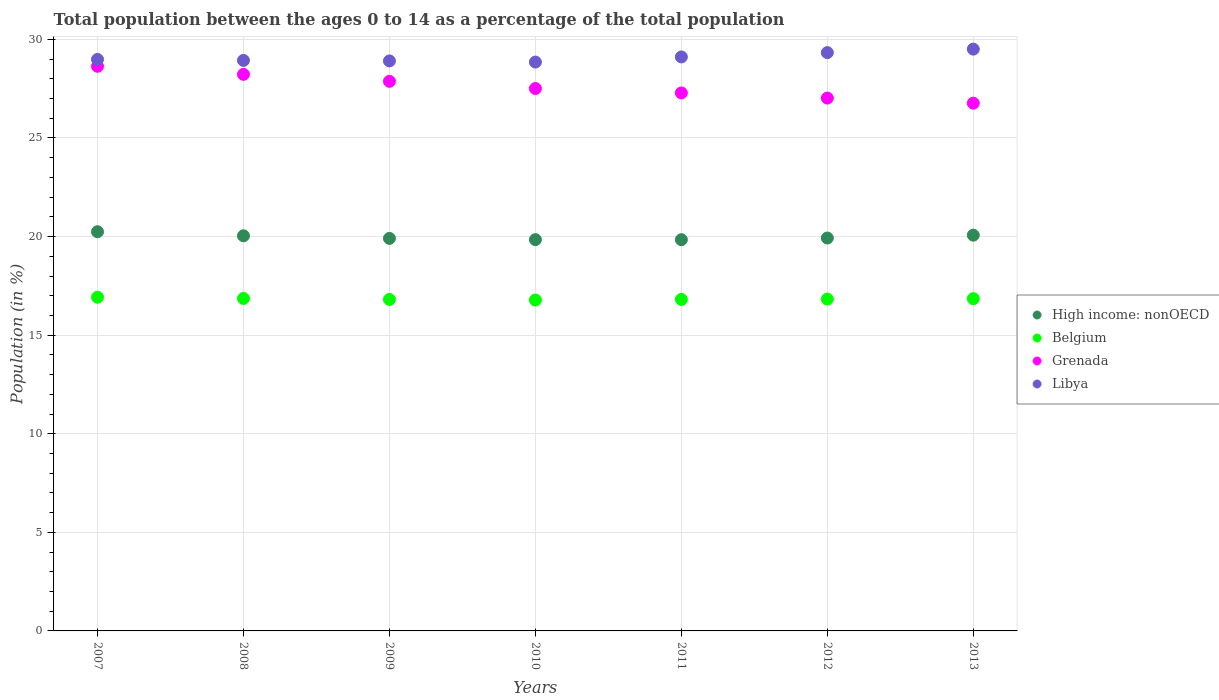What is the percentage of the population ages 0 to 14 in Libya in 2009?
Keep it short and to the point. 28.91. Across all years, what is the maximum percentage of the population ages 0 to 14 in High income: nonOECD?
Provide a short and direct response. 20.25. Across all years, what is the minimum percentage of the population ages 0 to 14 in Belgium?
Provide a short and direct response. 16.78. In which year was the percentage of the population ages 0 to 14 in Libya maximum?
Ensure brevity in your answer.  2013. In which year was the percentage of the population ages 0 to 14 in High income: nonOECD minimum?
Provide a succinct answer. 2011. What is the total percentage of the population ages 0 to 14 in High income: nonOECD in the graph?
Provide a short and direct response. 139.88. What is the difference between the percentage of the population ages 0 to 14 in Belgium in 2011 and that in 2013?
Ensure brevity in your answer.  -0.04. What is the difference between the percentage of the population ages 0 to 14 in Belgium in 2009 and the percentage of the population ages 0 to 14 in High income: nonOECD in 2010?
Offer a very short reply. -3.03. What is the average percentage of the population ages 0 to 14 in Libya per year?
Your answer should be compact. 29.09. In the year 2007, what is the difference between the percentage of the population ages 0 to 14 in Libya and percentage of the population ages 0 to 14 in Belgium?
Keep it short and to the point. 12.06. What is the ratio of the percentage of the population ages 0 to 14 in High income: nonOECD in 2011 to that in 2013?
Provide a short and direct response. 0.99. Is the difference between the percentage of the population ages 0 to 14 in Libya in 2007 and 2010 greater than the difference between the percentage of the population ages 0 to 14 in Belgium in 2007 and 2010?
Ensure brevity in your answer.  No. What is the difference between the highest and the second highest percentage of the population ages 0 to 14 in Grenada?
Offer a terse response. 0.41. What is the difference between the highest and the lowest percentage of the population ages 0 to 14 in High income: nonOECD?
Your answer should be compact. 0.4. In how many years, is the percentage of the population ages 0 to 14 in High income: nonOECD greater than the average percentage of the population ages 0 to 14 in High income: nonOECD taken over all years?
Keep it short and to the point. 3. Is the sum of the percentage of the population ages 0 to 14 in Libya in 2010 and 2012 greater than the maximum percentage of the population ages 0 to 14 in Belgium across all years?
Ensure brevity in your answer.  Yes. Is it the case that in every year, the sum of the percentage of the population ages 0 to 14 in High income: nonOECD and percentage of the population ages 0 to 14 in Libya  is greater than the sum of percentage of the population ages 0 to 14 in Grenada and percentage of the population ages 0 to 14 in Belgium?
Your response must be concise. Yes. Is the percentage of the population ages 0 to 14 in Libya strictly greater than the percentage of the population ages 0 to 14 in Grenada over the years?
Offer a terse response. Yes. Is the percentage of the population ages 0 to 14 in Libya strictly less than the percentage of the population ages 0 to 14 in Grenada over the years?
Offer a very short reply. No. What is the difference between two consecutive major ticks on the Y-axis?
Keep it short and to the point. 5. Are the values on the major ticks of Y-axis written in scientific E-notation?
Provide a short and direct response. No. What is the title of the graph?
Your response must be concise. Total population between the ages 0 to 14 as a percentage of the total population. Does "Afghanistan" appear as one of the legend labels in the graph?
Make the answer very short. No. What is the Population (in %) of High income: nonOECD in 2007?
Ensure brevity in your answer.  20.25. What is the Population (in %) in Belgium in 2007?
Provide a short and direct response. 16.92. What is the Population (in %) in Grenada in 2007?
Your answer should be compact. 28.64. What is the Population (in %) in Libya in 2007?
Provide a succinct answer. 28.99. What is the Population (in %) in High income: nonOECD in 2008?
Make the answer very short. 20.04. What is the Population (in %) in Belgium in 2008?
Your answer should be compact. 16.86. What is the Population (in %) of Grenada in 2008?
Provide a short and direct response. 28.23. What is the Population (in %) of Libya in 2008?
Make the answer very short. 28.93. What is the Population (in %) in High income: nonOECD in 2009?
Keep it short and to the point. 19.91. What is the Population (in %) of Belgium in 2009?
Offer a terse response. 16.81. What is the Population (in %) of Grenada in 2009?
Provide a short and direct response. 27.87. What is the Population (in %) of Libya in 2009?
Ensure brevity in your answer.  28.91. What is the Population (in %) of High income: nonOECD in 2010?
Provide a succinct answer. 19.85. What is the Population (in %) of Belgium in 2010?
Ensure brevity in your answer.  16.78. What is the Population (in %) in Grenada in 2010?
Provide a short and direct response. 27.51. What is the Population (in %) of Libya in 2010?
Give a very brief answer. 28.85. What is the Population (in %) of High income: nonOECD in 2011?
Provide a succinct answer. 19.84. What is the Population (in %) of Belgium in 2011?
Your response must be concise. 16.81. What is the Population (in %) of Grenada in 2011?
Make the answer very short. 27.29. What is the Population (in %) of Libya in 2011?
Offer a terse response. 29.11. What is the Population (in %) in High income: nonOECD in 2012?
Your response must be concise. 19.93. What is the Population (in %) in Belgium in 2012?
Offer a terse response. 16.83. What is the Population (in %) of Grenada in 2012?
Offer a very short reply. 27.02. What is the Population (in %) of Libya in 2012?
Offer a very short reply. 29.33. What is the Population (in %) of High income: nonOECD in 2013?
Your answer should be compact. 20.07. What is the Population (in %) in Belgium in 2013?
Ensure brevity in your answer.  16.85. What is the Population (in %) in Grenada in 2013?
Make the answer very short. 26.77. What is the Population (in %) in Libya in 2013?
Your answer should be compact. 29.51. Across all years, what is the maximum Population (in %) in High income: nonOECD?
Your answer should be compact. 20.25. Across all years, what is the maximum Population (in %) of Belgium?
Your answer should be very brief. 16.92. Across all years, what is the maximum Population (in %) in Grenada?
Make the answer very short. 28.64. Across all years, what is the maximum Population (in %) in Libya?
Make the answer very short. 29.51. Across all years, what is the minimum Population (in %) of High income: nonOECD?
Keep it short and to the point. 19.84. Across all years, what is the minimum Population (in %) in Belgium?
Provide a short and direct response. 16.78. Across all years, what is the minimum Population (in %) of Grenada?
Your answer should be compact. 26.77. Across all years, what is the minimum Population (in %) of Libya?
Offer a terse response. 28.85. What is the total Population (in %) of High income: nonOECD in the graph?
Provide a succinct answer. 139.88. What is the total Population (in %) of Belgium in the graph?
Give a very brief answer. 117.88. What is the total Population (in %) of Grenada in the graph?
Provide a short and direct response. 193.32. What is the total Population (in %) in Libya in the graph?
Provide a succinct answer. 203.63. What is the difference between the Population (in %) of High income: nonOECD in 2007 and that in 2008?
Your answer should be very brief. 0.21. What is the difference between the Population (in %) of Belgium in 2007 and that in 2008?
Your response must be concise. 0.06. What is the difference between the Population (in %) of Grenada in 2007 and that in 2008?
Provide a succinct answer. 0.41. What is the difference between the Population (in %) of Libya in 2007 and that in 2008?
Your answer should be compact. 0.05. What is the difference between the Population (in %) in High income: nonOECD in 2007 and that in 2009?
Your answer should be very brief. 0.34. What is the difference between the Population (in %) in Belgium in 2007 and that in 2009?
Your response must be concise. 0.11. What is the difference between the Population (in %) in Grenada in 2007 and that in 2009?
Give a very brief answer. 0.76. What is the difference between the Population (in %) of Libya in 2007 and that in 2009?
Your answer should be very brief. 0.08. What is the difference between the Population (in %) in High income: nonOECD in 2007 and that in 2010?
Your answer should be very brief. 0.4. What is the difference between the Population (in %) of Belgium in 2007 and that in 2010?
Keep it short and to the point. 0.14. What is the difference between the Population (in %) in Grenada in 2007 and that in 2010?
Your answer should be compact. 1.13. What is the difference between the Population (in %) of Libya in 2007 and that in 2010?
Make the answer very short. 0.14. What is the difference between the Population (in %) in High income: nonOECD in 2007 and that in 2011?
Ensure brevity in your answer.  0.4. What is the difference between the Population (in %) in Belgium in 2007 and that in 2011?
Offer a terse response. 0.11. What is the difference between the Population (in %) of Grenada in 2007 and that in 2011?
Your answer should be very brief. 1.35. What is the difference between the Population (in %) of Libya in 2007 and that in 2011?
Keep it short and to the point. -0.13. What is the difference between the Population (in %) in High income: nonOECD in 2007 and that in 2012?
Your answer should be compact. 0.32. What is the difference between the Population (in %) in Belgium in 2007 and that in 2012?
Your answer should be compact. 0.09. What is the difference between the Population (in %) in Grenada in 2007 and that in 2012?
Keep it short and to the point. 1.61. What is the difference between the Population (in %) of Libya in 2007 and that in 2012?
Keep it short and to the point. -0.34. What is the difference between the Population (in %) in High income: nonOECD in 2007 and that in 2013?
Provide a succinct answer. 0.17. What is the difference between the Population (in %) in Belgium in 2007 and that in 2013?
Provide a succinct answer. 0.07. What is the difference between the Population (in %) in Grenada in 2007 and that in 2013?
Provide a short and direct response. 1.87. What is the difference between the Population (in %) of Libya in 2007 and that in 2013?
Make the answer very short. -0.52. What is the difference between the Population (in %) of High income: nonOECD in 2008 and that in 2009?
Offer a very short reply. 0.13. What is the difference between the Population (in %) in Belgium in 2008 and that in 2009?
Make the answer very short. 0.05. What is the difference between the Population (in %) of Grenada in 2008 and that in 2009?
Offer a terse response. 0.35. What is the difference between the Population (in %) of Libya in 2008 and that in 2009?
Offer a very short reply. 0.03. What is the difference between the Population (in %) in High income: nonOECD in 2008 and that in 2010?
Provide a short and direct response. 0.2. What is the difference between the Population (in %) of Belgium in 2008 and that in 2010?
Your response must be concise. 0.08. What is the difference between the Population (in %) in Grenada in 2008 and that in 2010?
Your response must be concise. 0.72. What is the difference between the Population (in %) of Libya in 2008 and that in 2010?
Offer a terse response. 0.08. What is the difference between the Population (in %) in High income: nonOECD in 2008 and that in 2011?
Offer a very short reply. 0.2. What is the difference between the Population (in %) in Belgium in 2008 and that in 2011?
Ensure brevity in your answer.  0.05. What is the difference between the Population (in %) in Grenada in 2008 and that in 2011?
Your response must be concise. 0.94. What is the difference between the Population (in %) in Libya in 2008 and that in 2011?
Offer a very short reply. -0.18. What is the difference between the Population (in %) of High income: nonOECD in 2008 and that in 2012?
Your answer should be compact. 0.11. What is the difference between the Population (in %) of Belgium in 2008 and that in 2012?
Offer a very short reply. 0.03. What is the difference between the Population (in %) in Grenada in 2008 and that in 2012?
Your answer should be compact. 1.2. What is the difference between the Population (in %) in Libya in 2008 and that in 2012?
Your response must be concise. -0.4. What is the difference between the Population (in %) of High income: nonOECD in 2008 and that in 2013?
Make the answer very short. -0.03. What is the difference between the Population (in %) of Belgium in 2008 and that in 2013?
Make the answer very short. 0.01. What is the difference between the Population (in %) of Grenada in 2008 and that in 2013?
Give a very brief answer. 1.46. What is the difference between the Population (in %) in Libya in 2008 and that in 2013?
Your answer should be compact. -0.57. What is the difference between the Population (in %) in High income: nonOECD in 2009 and that in 2010?
Ensure brevity in your answer.  0.06. What is the difference between the Population (in %) in Belgium in 2009 and that in 2010?
Your answer should be compact. 0.03. What is the difference between the Population (in %) of Grenada in 2009 and that in 2010?
Give a very brief answer. 0.36. What is the difference between the Population (in %) of Libya in 2009 and that in 2010?
Ensure brevity in your answer.  0.06. What is the difference between the Population (in %) in High income: nonOECD in 2009 and that in 2011?
Keep it short and to the point. 0.06. What is the difference between the Population (in %) of Belgium in 2009 and that in 2011?
Your response must be concise. -0. What is the difference between the Population (in %) of Grenada in 2009 and that in 2011?
Give a very brief answer. 0.59. What is the difference between the Population (in %) in Libya in 2009 and that in 2011?
Offer a very short reply. -0.2. What is the difference between the Population (in %) in High income: nonOECD in 2009 and that in 2012?
Your answer should be compact. -0.02. What is the difference between the Population (in %) in Belgium in 2009 and that in 2012?
Keep it short and to the point. -0.02. What is the difference between the Population (in %) in Grenada in 2009 and that in 2012?
Offer a very short reply. 0.85. What is the difference between the Population (in %) in Libya in 2009 and that in 2012?
Give a very brief answer. -0.42. What is the difference between the Population (in %) of High income: nonOECD in 2009 and that in 2013?
Offer a very short reply. -0.16. What is the difference between the Population (in %) of Belgium in 2009 and that in 2013?
Provide a short and direct response. -0.04. What is the difference between the Population (in %) in Grenada in 2009 and that in 2013?
Provide a succinct answer. 1.11. What is the difference between the Population (in %) of Libya in 2009 and that in 2013?
Your answer should be very brief. -0.6. What is the difference between the Population (in %) in High income: nonOECD in 2010 and that in 2011?
Your response must be concise. 0. What is the difference between the Population (in %) in Belgium in 2010 and that in 2011?
Make the answer very short. -0.03. What is the difference between the Population (in %) in Grenada in 2010 and that in 2011?
Your response must be concise. 0.22. What is the difference between the Population (in %) in Libya in 2010 and that in 2011?
Provide a short and direct response. -0.26. What is the difference between the Population (in %) of High income: nonOECD in 2010 and that in 2012?
Offer a terse response. -0.08. What is the difference between the Population (in %) in Belgium in 2010 and that in 2012?
Your answer should be very brief. -0.05. What is the difference between the Population (in %) in Grenada in 2010 and that in 2012?
Keep it short and to the point. 0.49. What is the difference between the Population (in %) of Libya in 2010 and that in 2012?
Provide a succinct answer. -0.48. What is the difference between the Population (in %) of High income: nonOECD in 2010 and that in 2013?
Make the answer very short. -0.23. What is the difference between the Population (in %) of Belgium in 2010 and that in 2013?
Provide a succinct answer. -0.07. What is the difference between the Population (in %) in Grenada in 2010 and that in 2013?
Offer a terse response. 0.74. What is the difference between the Population (in %) in Libya in 2010 and that in 2013?
Make the answer very short. -0.66. What is the difference between the Population (in %) of High income: nonOECD in 2011 and that in 2012?
Provide a succinct answer. -0.08. What is the difference between the Population (in %) in Belgium in 2011 and that in 2012?
Give a very brief answer. -0.02. What is the difference between the Population (in %) in Grenada in 2011 and that in 2012?
Make the answer very short. 0.26. What is the difference between the Population (in %) of Libya in 2011 and that in 2012?
Make the answer very short. -0.22. What is the difference between the Population (in %) of High income: nonOECD in 2011 and that in 2013?
Offer a very short reply. -0.23. What is the difference between the Population (in %) in Belgium in 2011 and that in 2013?
Your answer should be very brief. -0.04. What is the difference between the Population (in %) in Grenada in 2011 and that in 2013?
Your answer should be very brief. 0.52. What is the difference between the Population (in %) in Libya in 2011 and that in 2013?
Keep it short and to the point. -0.4. What is the difference between the Population (in %) in High income: nonOECD in 2012 and that in 2013?
Offer a terse response. -0.14. What is the difference between the Population (in %) in Belgium in 2012 and that in 2013?
Provide a short and direct response. -0.02. What is the difference between the Population (in %) in Grenada in 2012 and that in 2013?
Offer a terse response. 0.26. What is the difference between the Population (in %) of Libya in 2012 and that in 2013?
Your answer should be very brief. -0.18. What is the difference between the Population (in %) in High income: nonOECD in 2007 and the Population (in %) in Belgium in 2008?
Your answer should be compact. 3.38. What is the difference between the Population (in %) in High income: nonOECD in 2007 and the Population (in %) in Grenada in 2008?
Ensure brevity in your answer.  -7.98. What is the difference between the Population (in %) in High income: nonOECD in 2007 and the Population (in %) in Libya in 2008?
Your answer should be very brief. -8.69. What is the difference between the Population (in %) of Belgium in 2007 and the Population (in %) of Grenada in 2008?
Your response must be concise. -11.3. What is the difference between the Population (in %) of Belgium in 2007 and the Population (in %) of Libya in 2008?
Give a very brief answer. -12.01. What is the difference between the Population (in %) of Grenada in 2007 and the Population (in %) of Libya in 2008?
Give a very brief answer. -0.3. What is the difference between the Population (in %) in High income: nonOECD in 2007 and the Population (in %) in Belgium in 2009?
Provide a succinct answer. 3.43. What is the difference between the Population (in %) in High income: nonOECD in 2007 and the Population (in %) in Grenada in 2009?
Provide a short and direct response. -7.63. What is the difference between the Population (in %) of High income: nonOECD in 2007 and the Population (in %) of Libya in 2009?
Your answer should be very brief. -8.66. What is the difference between the Population (in %) of Belgium in 2007 and the Population (in %) of Grenada in 2009?
Your response must be concise. -10.95. What is the difference between the Population (in %) of Belgium in 2007 and the Population (in %) of Libya in 2009?
Give a very brief answer. -11.98. What is the difference between the Population (in %) in Grenada in 2007 and the Population (in %) in Libya in 2009?
Keep it short and to the point. -0.27. What is the difference between the Population (in %) of High income: nonOECD in 2007 and the Population (in %) of Belgium in 2010?
Make the answer very short. 3.46. What is the difference between the Population (in %) in High income: nonOECD in 2007 and the Population (in %) in Grenada in 2010?
Offer a terse response. -7.26. What is the difference between the Population (in %) in High income: nonOECD in 2007 and the Population (in %) in Libya in 2010?
Keep it short and to the point. -8.6. What is the difference between the Population (in %) in Belgium in 2007 and the Population (in %) in Grenada in 2010?
Ensure brevity in your answer.  -10.59. What is the difference between the Population (in %) of Belgium in 2007 and the Population (in %) of Libya in 2010?
Your answer should be very brief. -11.93. What is the difference between the Population (in %) in Grenada in 2007 and the Population (in %) in Libya in 2010?
Ensure brevity in your answer.  -0.21. What is the difference between the Population (in %) of High income: nonOECD in 2007 and the Population (in %) of Belgium in 2011?
Your answer should be compact. 3.43. What is the difference between the Population (in %) of High income: nonOECD in 2007 and the Population (in %) of Grenada in 2011?
Ensure brevity in your answer.  -7.04. What is the difference between the Population (in %) of High income: nonOECD in 2007 and the Population (in %) of Libya in 2011?
Your answer should be very brief. -8.86. What is the difference between the Population (in %) of Belgium in 2007 and the Population (in %) of Grenada in 2011?
Keep it short and to the point. -10.36. What is the difference between the Population (in %) of Belgium in 2007 and the Population (in %) of Libya in 2011?
Ensure brevity in your answer.  -12.19. What is the difference between the Population (in %) of Grenada in 2007 and the Population (in %) of Libya in 2011?
Provide a succinct answer. -0.47. What is the difference between the Population (in %) in High income: nonOECD in 2007 and the Population (in %) in Belgium in 2012?
Your response must be concise. 3.41. What is the difference between the Population (in %) in High income: nonOECD in 2007 and the Population (in %) in Grenada in 2012?
Your answer should be very brief. -6.78. What is the difference between the Population (in %) of High income: nonOECD in 2007 and the Population (in %) of Libya in 2012?
Offer a terse response. -9.08. What is the difference between the Population (in %) in Belgium in 2007 and the Population (in %) in Grenada in 2012?
Offer a very short reply. -10.1. What is the difference between the Population (in %) of Belgium in 2007 and the Population (in %) of Libya in 2012?
Offer a terse response. -12.41. What is the difference between the Population (in %) of Grenada in 2007 and the Population (in %) of Libya in 2012?
Make the answer very short. -0.69. What is the difference between the Population (in %) in High income: nonOECD in 2007 and the Population (in %) in Belgium in 2013?
Keep it short and to the point. 3.39. What is the difference between the Population (in %) of High income: nonOECD in 2007 and the Population (in %) of Grenada in 2013?
Offer a very short reply. -6.52. What is the difference between the Population (in %) of High income: nonOECD in 2007 and the Population (in %) of Libya in 2013?
Keep it short and to the point. -9.26. What is the difference between the Population (in %) of Belgium in 2007 and the Population (in %) of Grenada in 2013?
Provide a succinct answer. -9.84. What is the difference between the Population (in %) in Belgium in 2007 and the Population (in %) in Libya in 2013?
Your response must be concise. -12.58. What is the difference between the Population (in %) in Grenada in 2007 and the Population (in %) in Libya in 2013?
Provide a short and direct response. -0.87. What is the difference between the Population (in %) of High income: nonOECD in 2008 and the Population (in %) of Belgium in 2009?
Your answer should be very brief. 3.23. What is the difference between the Population (in %) in High income: nonOECD in 2008 and the Population (in %) in Grenada in 2009?
Offer a terse response. -7.83. What is the difference between the Population (in %) of High income: nonOECD in 2008 and the Population (in %) of Libya in 2009?
Your response must be concise. -8.87. What is the difference between the Population (in %) in Belgium in 2008 and the Population (in %) in Grenada in 2009?
Offer a very short reply. -11.01. What is the difference between the Population (in %) in Belgium in 2008 and the Population (in %) in Libya in 2009?
Your response must be concise. -12.05. What is the difference between the Population (in %) in Grenada in 2008 and the Population (in %) in Libya in 2009?
Make the answer very short. -0.68. What is the difference between the Population (in %) in High income: nonOECD in 2008 and the Population (in %) in Belgium in 2010?
Your answer should be compact. 3.26. What is the difference between the Population (in %) of High income: nonOECD in 2008 and the Population (in %) of Grenada in 2010?
Your answer should be compact. -7.47. What is the difference between the Population (in %) of High income: nonOECD in 2008 and the Population (in %) of Libya in 2010?
Give a very brief answer. -8.81. What is the difference between the Population (in %) in Belgium in 2008 and the Population (in %) in Grenada in 2010?
Make the answer very short. -10.65. What is the difference between the Population (in %) in Belgium in 2008 and the Population (in %) in Libya in 2010?
Give a very brief answer. -11.99. What is the difference between the Population (in %) in Grenada in 2008 and the Population (in %) in Libya in 2010?
Provide a short and direct response. -0.62. What is the difference between the Population (in %) of High income: nonOECD in 2008 and the Population (in %) of Belgium in 2011?
Give a very brief answer. 3.23. What is the difference between the Population (in %) of High income: nonOECD in 2008 and the Population (in %) of Grenada in 2011?
Make the answer very short. -7.25. What is the difference between the Population (in %) in High income: nonOECD in 2008 and the Population (in %) in Libya in 2011?
Your answer should be compact. -9.07. What is the difference between the Population (in %) in Belgium in 2008 and the Population (in %) in Grenada in 2011?
Your answer should be compact. -10.42. What is the difference between the Population (in %) in Belgium in 2008 and the Population (in %) in Libya in 2011?
Provide a short and direct response. -12.25. What is the difference between the Population (in %) of Grenada in 2008 and the Population (in %) of Libya in 2011?
Your answer should be very brief. -0.88. What is the difference between the Population (in %) of High income: nonOECD in 2008 and the Population (in %) of Belgium in 2012?
Make the answer very short. 3.21. What is the difference between the Population (in %) of High income: nonOECD in 2008 and the Population (in %) of Grenada in 2012?
Provide a succinct answer. -6.98. What is the difference between the Population (in %) in High income: nonOECD in 2008 and the Population (in %) in Libya in 2012?
Provide a short and direct response. -9.29. What is the difference between the Population (in %) of Belgium in 2008 and the Population (in %) of Grenada in 2012?
Your answer should be very brief. -10.16. What is the difference between the Population (in %) in Belgium in 2008 and the Population (in %) in Libya in 2012?
Your answer should be compact. -12.47. What is the difference between the Population (in %) in Grenada in 2008 and the Population (in %) in Libya in 2012?
Give a very brief answer. -1.1. What is the difference between the Population (in %) of High income: nonOECD in 2008 and the Population (in %) of Belgium in 2013?
Your answer should be very brief. 3.19. What is the difference between the Population (in %) of High income: nonOECD in 2008 and the Population (in %) of Grenada in 2013?
Your answer should be compact. -6.72. What is the difference between the Population (in %) in High income: nonOECD in 2008 and the Population (in %) in Libya in 2013?
Your answer should be compact. -9.47. What is the difference between the Population (in %) of Belgium in 2008 and the Population (in %) of Grenada in 2013?
Provide a succinct answer. -9.9. What is the difference between the Population (in %) in Belgium in 2008 and the Population (in %) in Libya in 2013?
Your answer should be very brief. -12.65. What is the difference between the Population (in %) of Grenada in 2008 and the Population (in %) of Libya in 2013?
Offer a very short reply. -1.28. What is the difference between the Population (in %) in High income: nonOECD in 2009 and the Population (in %) in Belgium in 2010?
Offer a very short reply. 3.13. What is the difference between the Population (in %) in High income: nonOECD in 2009 and the Population (in %) in Grenada in 2010?
Keep it short and to the point. -7.6. What is the difference between the Population (in %) in High income: nonOECD in 2009 and the Population (in %) in Libya in 2010?
Ensure brevity in your answer.  -8.94. What is the difference between the Population (in %) of Belgium in 2009 and the Population (in %) of Grenada in 2010?
Make the answer very short. -10.7. What is the difference between the Population (in %) of Belgium in 2009 and the Population (in %) of Libya in 2010?
Ensure brevity in your answer.  -12.04. What is the difference between the Population (in %) of Grenada in 2009 and the Population (in %) of Libya in 2010?
Provide a succinct answer. -0.98. What is the difference between the Population (in %) in High income: nonOECD in 2009 and the Population (in %) in Belgium in 2011?
Provide a short and direct response. 3.09. What is the difference between the Population (in %) in High income: nonOECD in 2009 and the Population (in %) in Grenada in 2011?
Your response must be concise. -7.38. What is the difference between the Population (in %) in High income: nonOECD in 2009 and the Population (in %) in Libya in 2011?
Make the answer very short. -9.2. What is the difference between the Population (in %) in Belgium in 2009 and the Population (in %) in Grenada in 2011?
Your response must be concise. -10.47. What is the difference between the Population (in %) in Belgium in 2009 and the Population (in %) in Libya in 2011?
Provide a short and direct response. -12.3. What is the difference between the Population (in %) of Grenada in 2009 and the Population (in %) of Libya in 2011?
Your answer should be compact. -1.24. What is the difference between the Population (in %) of High income: nonOECD in 2009 and the Population (in %) of Belgium in 2012?
Provide a short and direct response. 3.08. What is the difference between the Population (in %) of High income: nonOECD in 2009 and the Population (in %) of Grenada in 2012?
Give a very brief answer. -7.12. What is the difference between the Population (in %) in High income: nonOECD in 2009 and the Population (in %) in Libya in 2012?
Ensure brevity in your answer.  -9.42. What is the difference between the Population (in %) in Belgium in 2009 and the Population (in %) in Grenada in 2012?
Your answer should be compact. -10.21. What is the difference between the Population (in %) in Belgium in 2009 and the Population (in %) in Libya in 2012?
Your answer should be compact. -12.52. What is the difference between the Population (in %) in Grenada in 2009 and the Population (in %) in Libya in 2012?
Offer a terse response. -1.46. What is the difference between the Population (in %) in High income: nonOECD in 2009 and the Population (in %) in Belgium in 2013?
Your response must be concise. 3.06. What is the difference between the Population (in %) of High income: nonOECD in 2009 and the Population (in %) of Grenada in 2013?
Ensure brevity in your answer.  -6.86. What is the difference between the Population (in %) in High income: nonOECD in 2009 and the Population (in %) in Libya in 2013?
Your answer should be compact. -9.6. What is the difference between the Population (in %) in Belgium in 2009 and the Population (in %) in Grenada in 2013?
Your answer should be very brief. -9.95. What is the difference between the Population (in %) in Belgium in 2009 and the Population (in %) in Libya in 2013?
Your response must be concise. -12.7. What is the difference between the Population (in %) of Grenada in 2009 and the Population (in %) of Libya in 2013?
Offer a very short reply. -1.63. What is the difference between the Population (in %) of High income: nonOECD in 2010 and the Population (in %) of Belgium in 2011?
Provide a short and direct response. 3.03. What is the difference between the Population (in %) of High income: nonOECD in 2010 and the Population (in %) of Grenada in 2011?
Offer a very short reply. -7.44. What is the difference between the Population (in %) in High income: nonOECD in 2010 and the Population (in %) in Libya in 2011?
Your answer should be very brief. -9.27. What is the difference between the Population (in %) in Belgium in 2010 and the Population (in %) in Grenada in 2011?
Your answer should be very brief. -10.5. What is the difference between the Population (in %) in Belgium in 2010 and the Population (in %) in Libya in 2011?
Ensure brevity in your answer.  -12.33. What is the difference between the Population (in %) in Grenada in 2010 and the Population (in %) in Libya in 2011?
Offer a very short reply. -1.6. What is the difference between the Population (in %) of High income: nonOECD in 2010 and the Population (in %) of Belgium in 2012?
Give a very brief answer. 3.01. What is the difference between the Population (in %) in High income: nonOECD in 2010 and the Population (in %) in Grenada in 2012?
Your answer should be very brief. -7.18. What is the difference between the Population (in %) of High income: nonOECD in 2010 and the Population (in %) of Libya in 2012?
Keep it short and to the point. -9.48. What is the difference between the Population (in %) in Belgium in 2010 and the Population (in %) in Grenada in 2012?
Keep it short and to the point. -10.24. What is the difference between the Population (in %) of Belgium in 2010 and the Population (in %) of Libya in 2012?
Provide a succinct answer. -12.55. What is the difference between the Population (in %) of Grenada in 2010 and the Population (in %) of Libya in 2012?
Offer a terse response. -1.82. What is the difference between the Population (in %) of High income: nonOECD in 2010 and the Population (in %) of Belgium in 2013?
Your answer should be very brief. 2.99. What is the difference between the Population (in %) in High income: nonOECD in 2010 and the Population (in %) in Grenada in 2013?
Your answer should be very brief. -6.92. What is the difference between the Population (in %) in High income: nonOECD in 2010 and the Population (in %) in Libya in 2013?
Keep it short and to the point. -9.66. What is the difference between the Population (in %) in Belgium in 2010 and the Population (in %) in Grenada in 2013?
Your answer should be very brief. -9.98. What is the difference between the Population (in %) in Belgium in 2010 and the Population (in %) in Libya in 2013?
Offer a terse response. -12.73. What is the difference between the Population (in %) in Grenada in 2010 and the Population (in %) in Libya in 2013?
Your answer should be compact. -2. What is the difference between the Population (in %) in High income: nonOECD in 2011 and the Population (in %) in Belgium in 2012?
Give a very brief answer. 3.01. What is the difference between the Population (in %) of High income: nonOECD in 2011 and the Population (in %) of Grenada in 2012?
Offer a terse response. -7.18. What is the difference between the Population (in %) of High income: nonOECD in 2011 and the Population (in %) of Libya in 2012?
Offer a terse response. -9.49. What is the difference between the Population (in %) of Belgium in 2011 and the Population (in %) of Grenada in 2012?
Your answer should be very brief. -10.21. What is the difference between the Population (in %) of Belgium in 2011 and the Population (in %) of Libya in 2012?
Offer a terse response. -12.52. What is the difference between the Population (in %) in Grenada in 2011 and the Population (in %) in Libya in 2012?
Keep it short and to the point. -2.04. What is the difference between the Population (in %) in High income: nonOECD in 2011 and the Population (in %) in Belgium in 2013?
Give a very brief answer. 2.99. What is the difference between the Population (in %) in High income: nonOECD in 2011 and the Population (in %) in Grenada in 2013?
Make the answer very short. -6.92. What is the difference between the Population (in %) of High income: nonOECD in 2011 and the Population (in %) of Libya in 2013?
Keep it short and to the point. -9.66. What is the difference between the Population (in %) of Belgium in 2011 and the Population (in %) of Grenada in 2013?
Your response must be concise. -9.95. What is the difference between the Population (in %) in Belgium in 2011 and the Population (in %) in Libya in 2013?
Give a very brief answer. -12.69. What is the difference between the Population (in %) in Grenada in 2011 and the Population (in %) in Libya in 2013?
Your response must be concise. -2.22. What is the difference between the Population (in %) in High income: nonOECD in 2012 and the Population (in %) in Belgium in 2013?
Provide a short and direct response. 3.07. What is the difference between the Population (in %) of High income: nonOECD in 2012 and the Population (in %) of Grenada in 2013?
Offer a very short reply. -6.84. What is the difference between the Population (in %) of High income: nonOECD in 2012 and the Population (in %) of Libya in 2013?
Provide a succinct answer. -9.58. What is the difference between the Population (in %) of Belgium in 2012 and the Population (in %) of Grenada in 2013?
Your answer should be very brief. -9.93. What is the difference between the Population (in %) in Belgium in 2012 and the Population (in %) in Libya in 2013?
Provide a succinct answer. -12.68. What is the difference between the Population (in %) in Grenada in 2012 and the Population (in %) in Libya in 2013?
Give a very brief answer. -2.48. What is the average Population (in %) of High income: nonOECD per year?
Your answer should be very brief. 19.98. What is the average Population (in %) of Belgium per year?
Your response must be concise. 16.84. What is the average Population (in %) in Grenada per year?
Your answer should be very brief. 27.62. What is the average Population (in %) of Libya per year?
Provide a short and direct response. 29.09. In the year 2007, what is the difference between the Population (in %) in High income: nonOECD and Population (in %) in Belgium?
Offer a terse response. 3.32. In the year 2007, what is the difference between the Population (in %) in High income: nonOECD and Population (in %) in Grenada?
Provide a succinct answer. -8.39. In the year 2007, what is the difference between the Population (in %) in High income: nonOECD and Population (in %) in Libya?
Your answer should be compact. -8.74. In the year 2007, what is the difference between the Population (in %) of Belgium and Population (in %) of Grenada?
Provide a short and direct response. -11.71. In the year 2007, what is the difference between the Population (in %) in Belgium and Population (in %) in Libya?
Your answer should be very brief. -12.06. In the year 2007, what is the difference between the Population (in %) in Grenada and Population (in %) in Libya?
Offer a terse response. -0.35. In the year 2008, what is the difference between the Population (in %) in High income: nonOECD and Population (in %) in Belgium?
Keep it short and to the point. 3.18. In the year 2008, what is the difference between the Population (in %) in High income: nonOECD and Population (in %) in Grenada?
Offer a terse response. -8.19. In the year 2008, what is the difference between the Population (in %) in High income: nonOECD and Population (in %) in Libya?
Offer a terse response. -8.89. In the year 2008, what is the difference between the Population (in %) in Belgium and Population (in %) in Grenada?
Your answer should be very brief. -11.37. In the year 2008, what is the difference between the Population (in %) of Belgium and Population (in %) of Libya?
Keep it short and to the point. -12.07. In the year 2008, what is the difference between the Population (in %) in Grenada and Population (in %) in Libya?
Keep it short and to the point. -0.71. In the year 2009, what is the difference between the Population (in %) of High income: nonOECD and Population (in %) of Belgium?
Provide a succinct answer. 3.1. In the year 2009, what is the difference between the Population (in %) of High income: nonOECD and Population (in %) of Grenada?
Ensure brevity in your answer.  -7.97. In the year 2009, what is the difference between the Population (in %) of High income: nonOECD and Population (in %) of Libya?
Your response must be concise. -9. In the year 2009, what is the difference between the Population (in %) of Belgium and Population (in %) of Grenada?
Offer a very short reply. -11.06. In the year 2009, what is the difference between the Population (in %) in Belgium and Population (in %) in Libya?
Give a very brief answer. -12.1. In the year 2009, what is the difference between the Population (in %) of Grenada and Population (in %) of Libya?
Make the answer very short. -1.03. In the year 2010, what is the difference between the Population (in %) in High income: nonOECD and Population (in %) in Belgium?
Your answer should be very brief. 3.06. In the year 2010, what is the difference between the Population (in %) of High income: nonOECD and Population (in %) of Grenada?
Your response must be concise. -7.67. In the year 2010, what is the difference between the Population (in %) of High income: nonOECD and Population (in %) of Libya?
Ensure brevity in your answer.  -9.01. In the year 2010, what is the difference between the Population (in %) of Belgium and Population (in %) of Grenada?
Provide a short and direct response. -10.73. In the year 2010, what is the difference between the Population (in %) of Belgium and Population (in %) of Libya?
Make the answer very short. -12.07. In the year 2010, what is the difference between the Population (in %) in Grenada and Population (in %) in Libya?
Your response must be concise. -1.34. In the year 2011, what is the difference between the Population (in %) of High income: nonOECD and Population (in %) of Belgium?
Provide a short and direct response. 3.03. In the year 2011, what is the difference between the Population (in %) of High income: nonOECD and Population (in %) of Grenada?
Make the answer very short. -7.44. In the year 2011, what is the difference between the Population (in %) in High income: nonOECD and Population (in %) in Libya?
Your response must be concise. -9.27. In the year 2011, what is the difference between the Population (in %) in Belgium and Population (in %) in Grenada?
Offer a very short reply. -10.47. In the year 2011, what is the difference between the Population (in %) of Belgium and Population (in %) of Libya?
Offer a very short reply. -12.3. In the year 2011, what is the difference between the Population (in %) of Grenada and Population (in %) of Libya?
Offer a very short reply. -1.83. In the year 2012, what is the difference between the Population (in %) of High income: nonOECD and Population (in %) of Belgium?
Provide a short and direct response. 3.09. In the year 2012, what is the difference between the Population (in %) of High income: nonOECD and Population (in %) of Grenada?
Make the answer very short. -7.1. In the year 2012, what is the difference between the Population (in %) in High income: nonOECD and Population (in %) in Libya?
Your response must be concise. -9.4. In the year 2012, what is the difference between the Population (in %) of Belgium and Population (in %) of Grenada?
Your answer should be very brief. -10.19. In the year 2012, what is the difference between the Population (in %) in Belgium and Population (in %) in Libya?
Offer a very short reply. -12.5. In the year 2012, what is the difference between the Population (in %) of Grenada and Population (in %) of Libya?
Keep it short and to the point. -2.31. In the year 2013, what is the difference between the Population (in %) in High income: nonOECD and Population (in %) in Belgium?
Make the answer very short. 3.22. In the year 2013, what is the difference between the Population (in %) in High income: nonOECD and Population (in %) in Grenada?
Keep it short and to the point. -6.69. In the year 2013, what is the difference between the Population (in %) in High income: nonOECD and Population (in %) in Libya?
Your response must be concise. -9.44. In the year 2013, what is the difference between the Population (in %) of Belgium and Population (in %) of Grenada?
Provide a succinct answer. -9.91. In the year 2013, what is the difference between the Population (in %) in Belgium and Population (in %) in Libya?
Your answer should be compact. -12.65. In the year 2013, what is the difference between the Population (in %) in Grenada and Population (in %) in Libya?
Make the answer very short. -2.74. What is the ratio of the Population (in %) in High income: nonOECD in 2007 to that in 2008?
Your response must be concise. 1.01. What is the ratio of the Population (in %) in Grenada in 2007 to that in 2008?
Offer a terse response. 1.01. What is the ratio of the Population (in %) of High income: nonOECD in 2007 to that in 2009?
Make the answer very short. 1.02. What is the ratio of the Population (in %) in Grenada in 2007 to that in 2009?
Offer a very short reply. 1.03. What is the ratio of the Population (in %) of Libya in 2007 to that in 2009?
Your response must be concise. 1. What is the ratio of the Population (in %) of High income: nonOECD in 2007 to that in 2010?
Keep it short and to the point. 1.02. What is the ratio of the Population (in %) in Belgium in 2007 to that in 2010?
Offer a terse response. 1.01. What is the ratio of the Population (in %) of Grenada in 2007 to that in 2010?
Ensure brevity in your answer.  1.04. What is the ratio of the Population (in %) of Libya in 2007 to that in 2010?
Make the answer very short. 1. What is the ratio of the Population (in %) in High income: nonOECD in 2007 to that in 2011?
Offer a terse response. 1.02. What is the ratio of the Population (in %) of Belgium in 2007 to that in 2011?
Offer a very short reply. 1.01. What is the ratio of the Population (in %) in Grenada in 2007 to that in 2011?
Offer a terse response. 1.05. What is the ratio of the Population (in %) of Libya in 2007 to that in 2011?
Your answer should be compact. 1. What is the ratio of the Population (in %) in High income: nonOECD in 2007 to that in 2012?
Ensure brevity in your answer.  1.02. What is the ratio of the Population (in %) in Belgium in 2007 to that in 2012?
Provide a short and direct response. 1.01. What is the ratio of the Population (in %) of Grenada in 2007 to that in 2012?
Your response must be concise. 1.06. What is the ratio of the Population (in %) of Libya in 2007 to that in 2012?
Keep it short and to the point. 0.99. What is the ratio of the Population (in %) in High income: nonOECD in 2007 to that in 2013?
Ensure brevity in your answer.  1.01. What is the ratio of the Population (in %) of Belgium in 2007 to that in 2013?
Ensure brevity in your answer.  1. What is the ratio of the Population (in %) of Grenada in 2007 to that in 2013?
Provide a succinct answer. 1.07. What is the ratio of the Population (in %) of Libya in 2007 to that in 2013?
Your answer should be very brief. 0.98. What is the ratio of the Population (in %) in High income: nonOECD in 2008 to that in 2009?
Offer a terse response. 1.01. What is the ratio of the Population (in %) of Belgium in 2008 to that in 2009?
Your answer should be very brief. 1. What is the ratio of the Population (in %) in Grenada in 2008 to that in 2009?
Provide a short and direct response. 1.01. What is the ratio of the Population (in %) in High income: nonOECD in 2008 to that in 2010?
Make the answer very short. 1.01. What is the ratio of the Population (in %) of Grenada in 2008 to that in 2010?
Make the answer very short. 1.03. What is the ratio of the Population (in %) of High income: nonOECD in 2008 to that in 2011?
Offer a very short reply. 1.01. What is the ratio of the Population (in %) in Belgium in 2008 to that in 2011?
Your response must be concise. 1. What is the ratio of the Population (in %) in Grenada in 2008 to that in 2011?
Make the answer very short. 1.03. What is the ratio of the Population (in %) in Libya in 2008 to that in 2011?
Provide a short and direct response. 0.99. What is the ratio of the Population (in %) in Belgium in 2008 to that in 2012?
Give a very brief answer. 1. What is the ratio of the Population (in %) of Grenada in 2008 to that in 2012?
Your response must be concise. 1.04. What is the ratio of the Population (in %) in Libya in 2008 to that in 2012?
Give a very brief answer. 0.99. What is the ratio of the Population (in %) of High income: nonOECD in 2008 to that in 2013?
Provide a succinct answer. 1. What is the ratio of the Population (in %) in Grenada in 2008 to that in 2013?
Your answer should be very brief. 1.05. What is the ratio of the Population (in %) of Libya in 2008 to that in 2013?
Keep it short and to the point. 0.98. What is the ratio of the Population (in %) in High income: nonOECD in 2009 to that in 2010?
Make the answer very short. 1. What is the ratio of the Population (in %) in Grenada in 2009 to that in 2010?
Ensure brevity in your answer.  1.01. What is the ratio of the Population (in %) of High income: nonOECD in 2009 to that in 2011?
Give a very brief answer. 1. What is the ratio of the Population (in %) in Grenada in 2009 to that in 2011?
Keep it short and to the point. 1.02. What is the ratio of the Population (in %) of Libya in 2009 to that in 2011?
Offer a terse response. 0.99. What is the ratio of the Population (in %) in High income: nonOECD in 2009 to that in 2012?
Offer a very short reply. 1. What is the ratio of the Population (in %) in Belgium in 2009 to that in 2012?
Make the answer very short. 1. What is the ratio of the Population (in %) of Grenada in 2009 to that in 2012?
Ensure brevity in your answer.  1.03. What is the ratio of the Population (in %) of Libya in 2009 to that in 2012?
Ensure brevity in your answer.  0.99. What is the ratio of the Population (in %) of Grenada in 2009 to that in 2013?
Your response must be concise. 1.04. What is the ratio of the Population (in %) of Libya in 2009 to that in 2013?
Make the answer very short. 0.98. What is the ratio of the Population (in %) of Belgium in 2010 to that in 2011?
Provide a succinct answer. 1. What is the ratio of the Population (in %) in Grenada in 2010 to that in 2011?
Ensure brevity in your answer.  1.01. What is the ratio of the Population (in %) of Libya in 2010 to that in 2011?
Your answer should be compact. 0.99. What is the ratio of the Population (in %) of Libya in 2010 to that in 2012?
Keep it short and to the point. 0.98. What is the ratio of the Population (in %) of High income: nonOECD in 2010 to that in 2013?
Offer a very short reply. 0.99. What is the ratio of the Population (in %) of Grenada in 2010 to that in 2013?
Provide a short and direct response. 1.03. What is the ratio of the Population (in %) of Libya in 2010 to that in 2013?
Make the answer very short. 0.98. What is the ratio of the Population (in %) of Grenada in 2011 to that in 2012?
Your answer should be very brief. 1.01. What is the ratio of the Population (in %) of Grenada in 2011 to that in 2013?
Offer a terse response. 1.02. What is the ratio of the Population (in %) in Libya in 2011 to that in 2013?
Offer a terse response. 0.99. What is the ratio of the Population (in %) in High income: nonOECD in 2012 to that in 2013?
Your answer should be compact. 0.99. What is the ratio of the Population (in %) in Grenada in 2012 to that in 2013?
Offer a terse response. 1.01. What is the ratio of the Population (in %) of Libya in 2012 to that in 2013?
Offer a terse response. 0.99. What is the difference between the highest and the second highest Population (in %) in High income: nonOECD?
Ensure brevity in your answer.  0.17. What is the difference between the highest and the second highest Population (in %) in Belgium?
Ensure brevity in your answer.  0.06. What is the difference between the highest and the second highest Population (in %) of Grenada?
Ensure brevity in your answer.  0.41. What is the difference between the highest and the second highest Population (in %) in Libya?
Make the answer very short. 0.18. What is the difference between the highest and the lowest Population (in %) in High income: nonOECD?
Keep it short and to the point. 0.4. What is the difference between the highest and the lowest Population (in %) in Belgium?
Provide a short and direct response. 0.14. What is the difference between the highest and the lowest Population (in %) in Grenada?
Your answer should be very brief. 1.87. What is the difference between the highest and the lowest Population (in %) of Libya?
Offer a terse response. 0.66. 